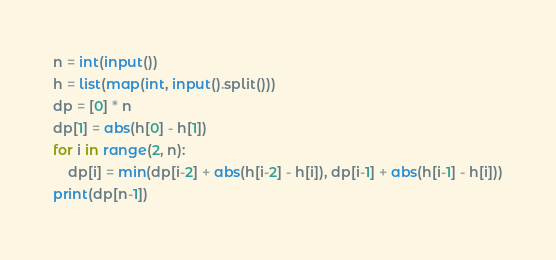<code> <loc_0><loc_0><loc_500><loc_500><_Python_>n = int(input())
h = list(map(int, input().split()))
dp = [0] * n
dp[1] = abs(h[0] - h[1])
for i in range(2, n):
	dp[i] = min(dp[i-2] + abs(h[i-2] - h[i]), dp[i-1] + abs(h[i-1] - h[i]))
print(dp[n-1])</code> 